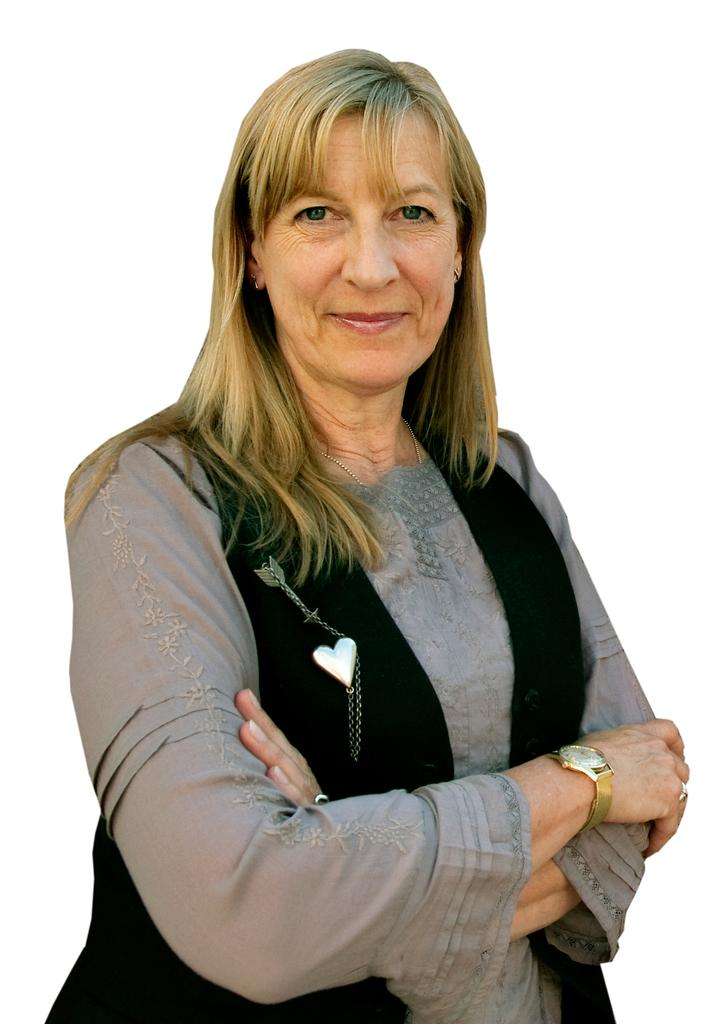Who is the main subject in the image? There is a woman in the image. What is the woman doing in the image? The woman is standing. What color jacket is the woman wearing? The woman is wearing a black color jacket. What is the color of the background in the image? The background of the image is white. Can you tell me how many properties the woman owns in the image? There is no information about the woman's properties in the image. What type of train can be seen in the background of the image? There is no train present in the image; the background is white. 